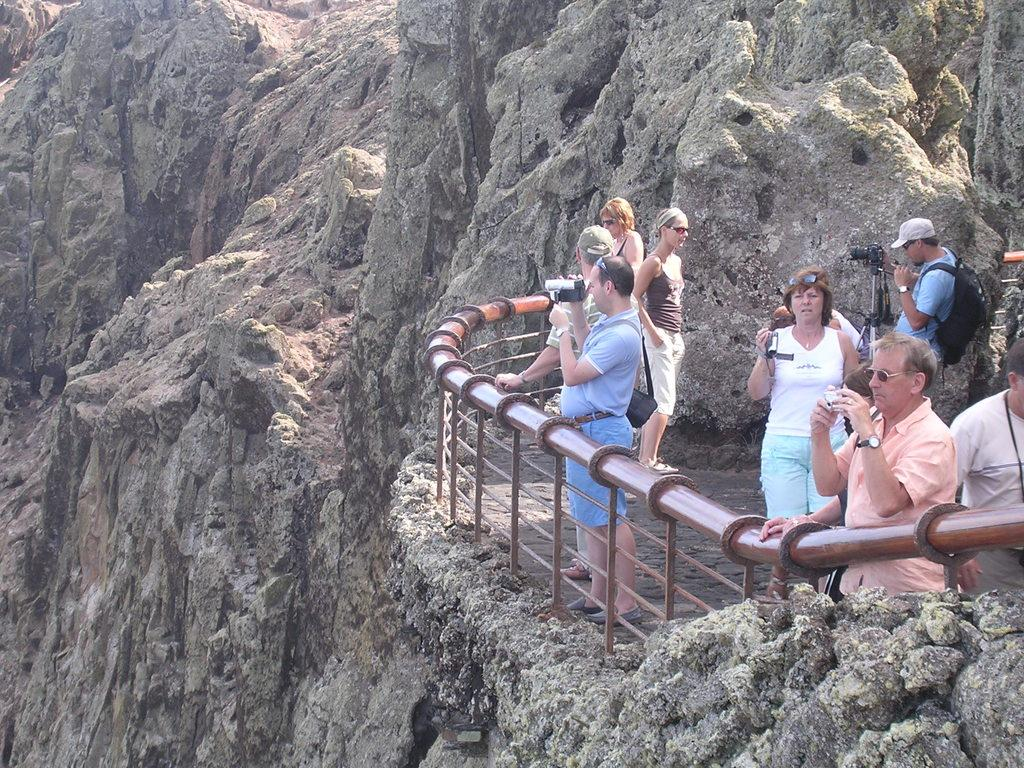What can be seen in the image involving people? There are people standing in the image. What equipment is present in the image related to photography? There is a camera with a tripod stand in the image. What type of landscape is depicted in the image? The image appears to depict mountains. What type of barrier is visible in the image? There is a fence in the image. What type of pie is being served in the image? There is no pie present in the image; it depicts people, a camera with a tripod stand, mountains, and a fence. How many steps are visible in the image? There is no mention of steps in the image; it features people, a camera with a tripod stand, mountains, and a fence. 